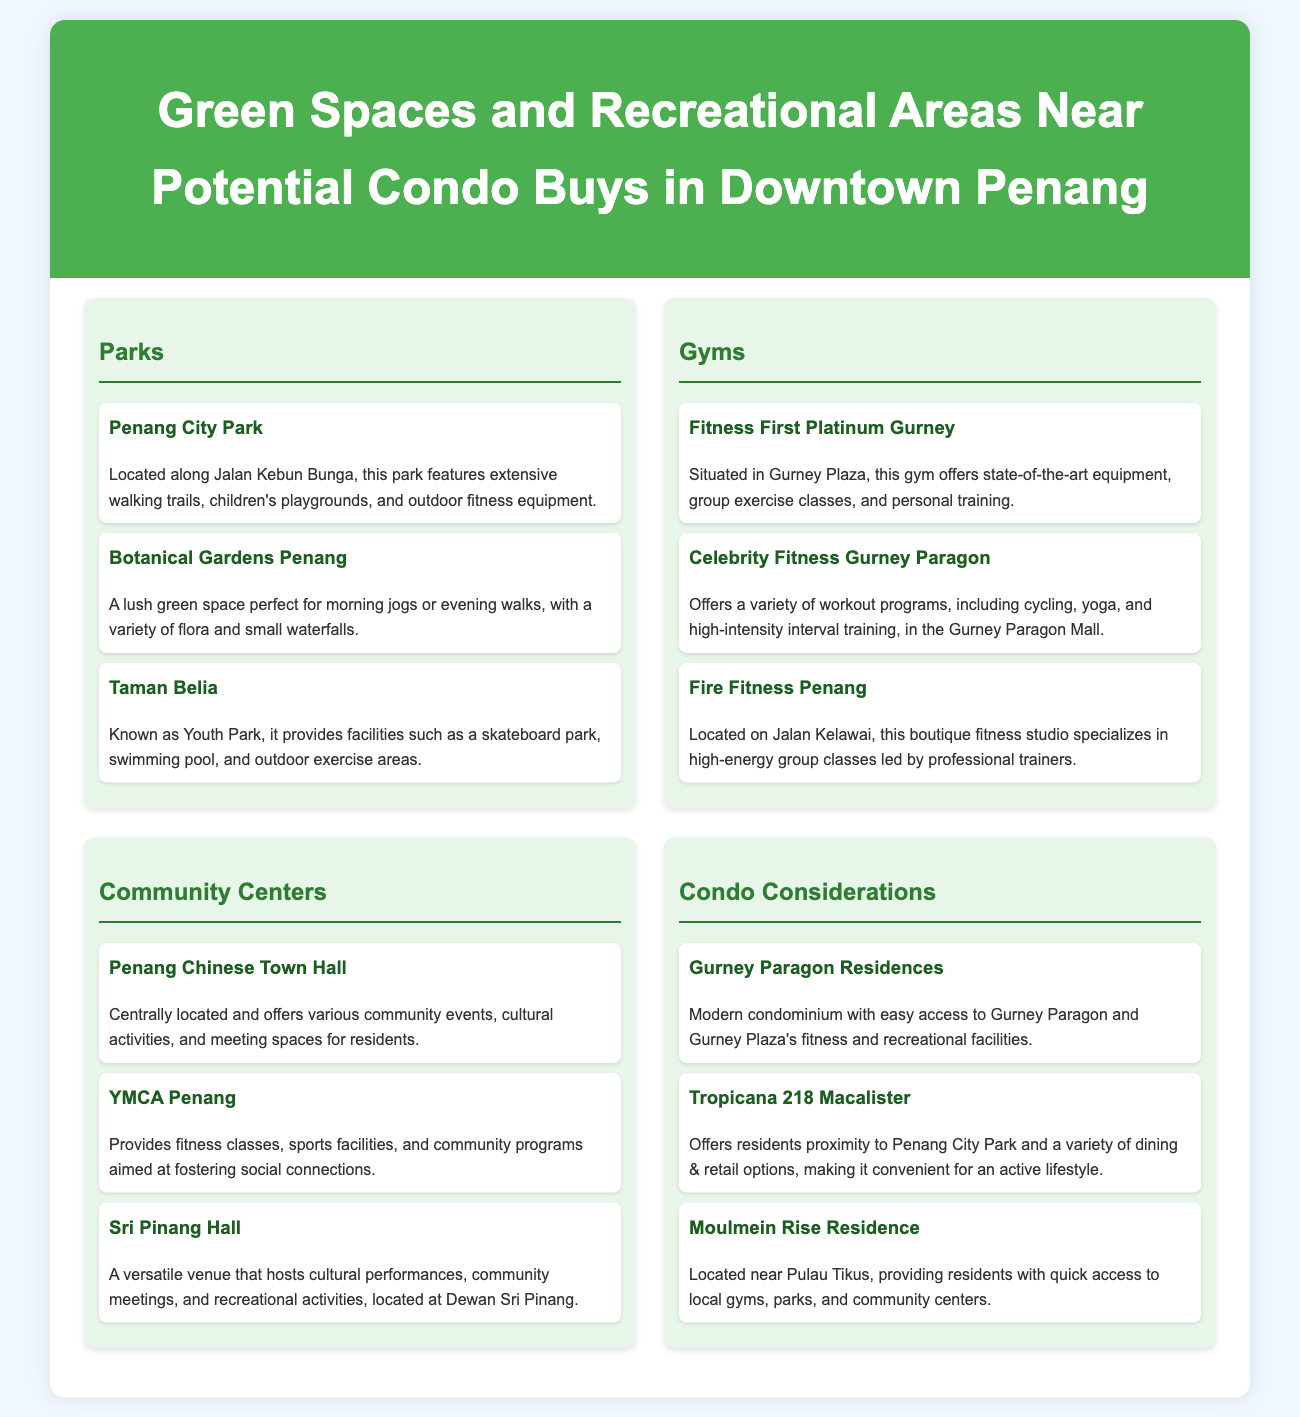What is the location of Penang City Park? The document specifies that Penang City Park is located along Jalan Kebun Bunga.
Answer: Jalan Kebun Bunga What facilities does Taman Belia provide? Taman Belia, known as Youth Park, provides facilities such as a skateboard park, swimming pool, and outdoor exercise areas.
Answer: Skateboard park, swimming pool, outdoor exercise areas How many gyms are listed in the document? There are a total of three gyms mentioned in the document, namely Fitness First Platinum Gurney, Celebrity Fitness Gurney Paragon, and Fire Fitness Penang.
Answer: Three Which community center is located centrally? The document mentions the Penang Chinese Town Hall as a centrally located community center offering various events and activities.
Answer: Penang Chinese Town Hall What is the name of the gym located on Jalan Kelawai? Fire Fitness Penang is the gym mentioned that is located on Jalan Kelawai.
Answer: Fire Fitness Penang What condominium is near Penang City Park? The document specifies that Tropicana 218 Macalister offers residents proximity to Penang City Park.
Answer: Tropicana 218 Macalister What type of activities does YMCA Penang provide? The document states that YMCA Penang provides fitness classes, sports facilities, and community programs.
Answer: Fitness classes, sports facilities, community programs Which park features small waterfalls? The Botanical Gardens Penang is noted for its lush greenery and small waterfalls.
Answer: Botanical Gardens Penang How many sections are there in the document discussing recreational areas? The document contains three sections that discuss parks, gyms, and community centers.
Answer: Three 